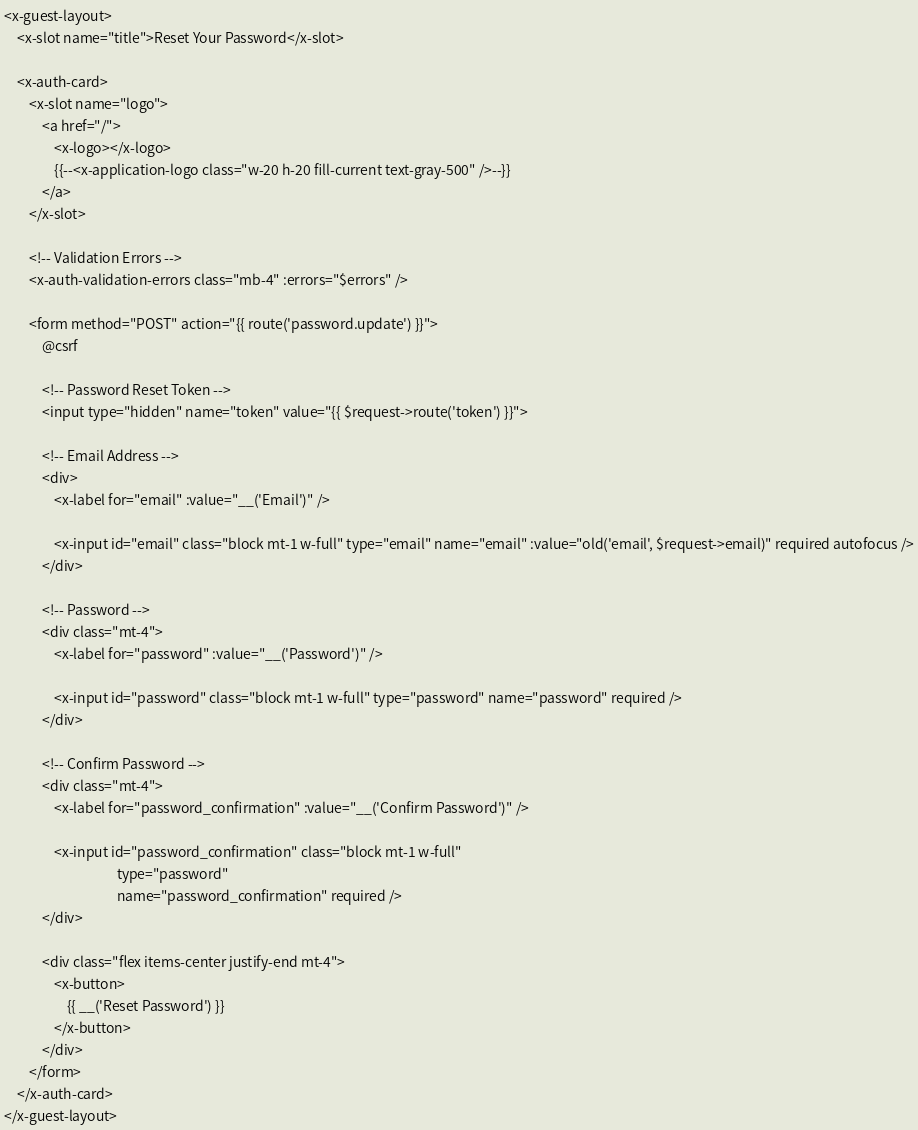Convert code to text. <code><loc_0><loc_0><loc_500><loc_500><_PHP_><x-guest-layout>
    <x-slot name="title">Reset Your Password</x-slot>

    <x-auth-card>
        <x-slot name="logo">
            <a href="/">
                <x-logo></x-logo>
                {{--<x-application-logo class="w-20 h-20 fill-current text-gray-500" />--}}
            </a>
        </x-slot>

        <!-- Validation Errors -->
        <x-auth-validation-errors class="mb-4" :errors="$errors" />

        <form method="POST" action="{{ route('password.update') }}">
            @csrf

            <!-- Password Reset Token -->
            <input type="hidden" name="token" value="{{ $request->route('token') }}">

            <!-- Email Address -->
            <div>
                <x-label for="email" :value="__('Email')" />

                <x-input id="email" class="block mt-1 w-full" type="email" name="email" :value="old('email', $request->email)" required autofocus />
            </div>

            <!-- Password -->
            <div class="mt-4">
                <x-label for="password" :value="__('Password')" />

                <x-input id="password" class="block mt-1 w-full" type="password" name="password" required />
            </div>

            <!-- Confirm Password -->
            <div class="mt-4">
                <x-label for="password_confirmation" :value="__('Confirm Password')" />

                <x-input id="password_confirmation" class="block mt-1 w-full"
                                    type="password"
                                    name="password_confirmation" required />
            </div>

            <div class="flex items-center justify-end mt-4">
                <x-button>
                    {{ __('Reset Password') }}
                </x-button>
            </div>
        </form>
    </x-auth-card>
</x-guest-layout>
</code> 